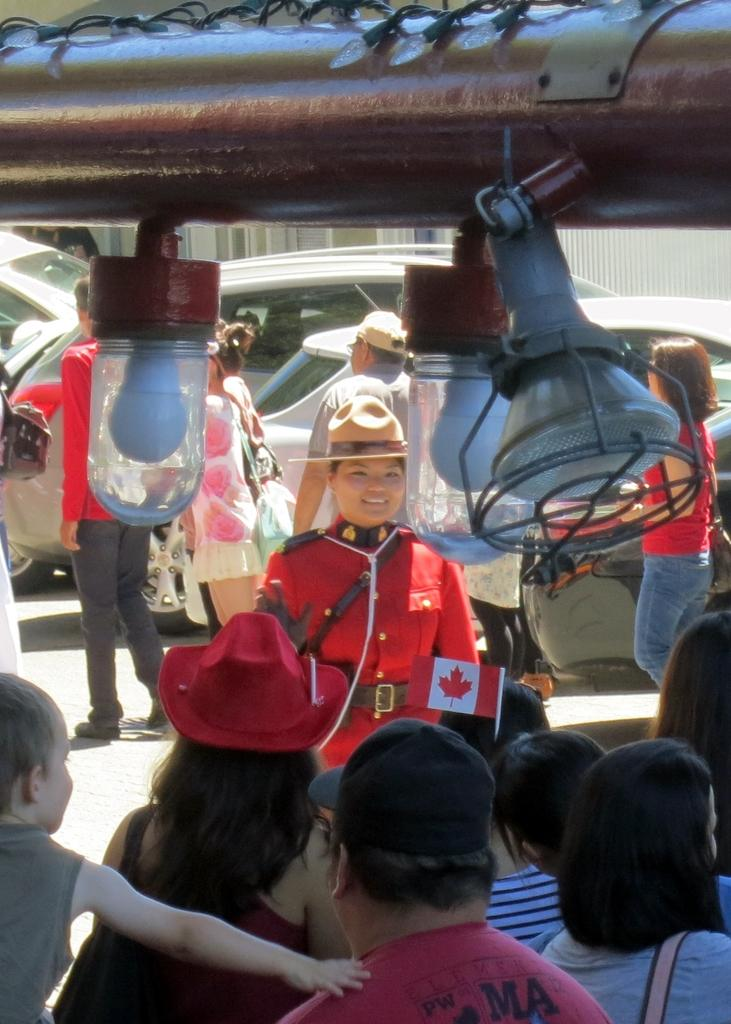What are the people in the image doing? The people in the image are standing at the bottom and watching something. What can be seen behind the people? There are vehicles behind the people. What is located at the top of the image? There is a pipe at the top of the image. What is special about the pipe? There are lights on the pipe. What type of lip can be seen on the ship in the image? There is no ship present in the image, and therefore no lip can be seen. What is the blade used for in the image? There is no blade present in the image. 